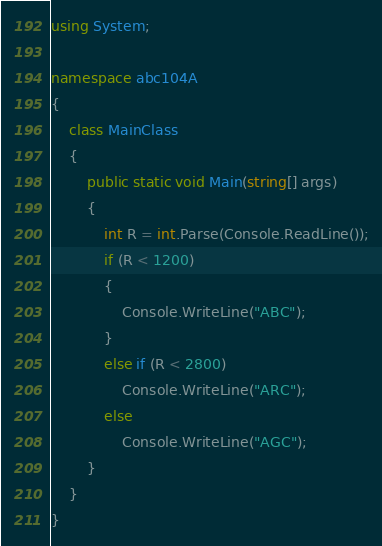Convert code to text. <code><loc_0><loc_0><loc_500><loc_500><_C#_>using System;

namespace abc104A
{
    class MainClass
    {
        public static void Main(string[] args)
        {
            int R = int.Parse(Console.ReadLine());
            if (R < 1200)
            {
                Console.WriteLine("ABC");
            }
            else if (R < 2800)
                Console.WriteLine("ARC");
            else
                Console.WriteLine("AGC");
        }
    }
}
</code> 